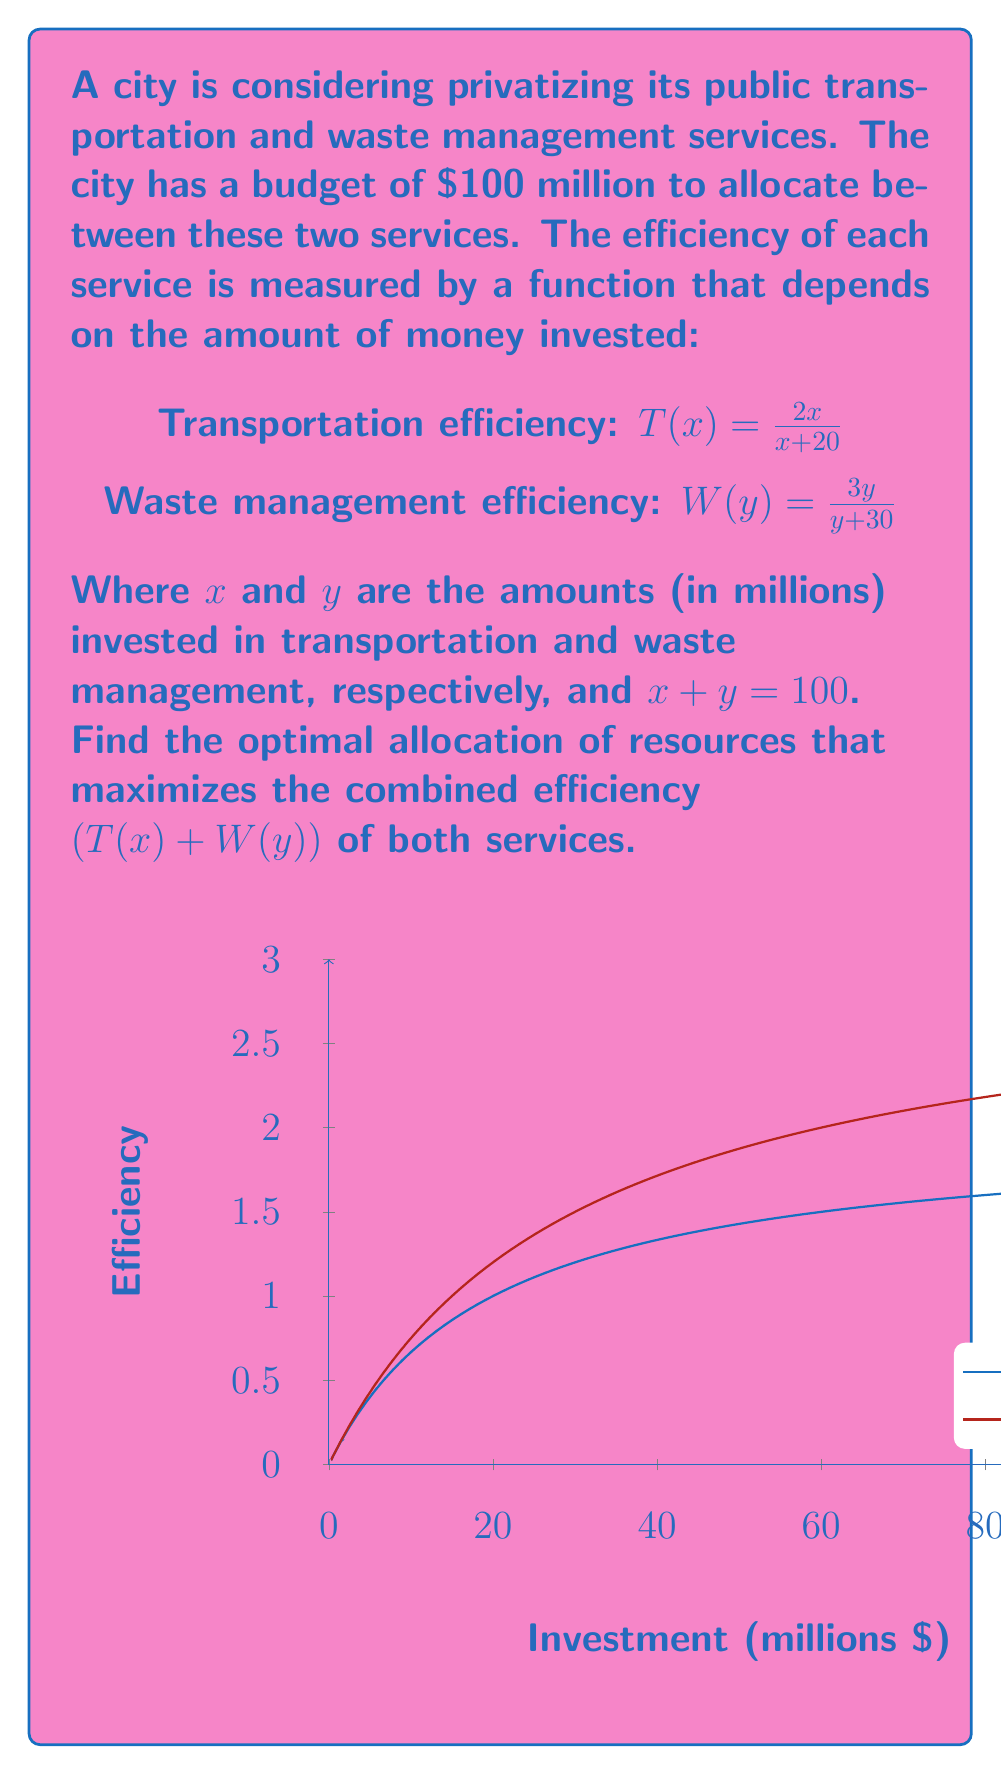Show me your answer to this math problem. To solve this problem, we'll use the method of Lagrange multipliers:

1) Let's define the function to maximize:
   $f(x,y) = T(x) + W(y) = \frac{2x}{x+20} + \frac{3y}{y+30}$

2) The constraint is:
   $g(x,y) = x + y - 100 = 0$

3) Form the Lagrangian:
   $L(x,y,\lambda) = f(x,y) - \lambda g(x,y) = \frac{2x}{x+20} + \frac{3y}{y+30} - \lambda(x + y - 100)$

4) Take partial derivatives and set them to zero:
   $\frac{\partial L}{\partial x} = \frac{40}{(x+20)^2} - \lambda = 0$
   $\frac{\partial L}{\partial y} = \frac{90}{(y+30)^2} - \lambda = 0$
   $\frac{\partial L}{\partial \lambda} = x + y - 100 = 0$

5) From the first two equations:
   $\frac{40}{(x+20)^2} = \frac{90}{(y+30)^2}$

6) This implies:
   $\frac{x+20}{y+30} = \frac{3}{2}$

7) Substitute $y = 100 - x$ from the constraint:
   $\frac{x+20}{130-x} = \frac{3}{2}$

8) Solve this equation:
   $2(x+20) = 3(130-x)$
   $2x + 40 = 390 - 3x$
   $5x = 350$
   $x = 70$

9) Therefore, $y = 100 - 70 = 30$

10) Verify that this indeed maximizes the function by checking the second derivative or by plotting.
Answer: $x = 70$ million, $y = 30$ million 